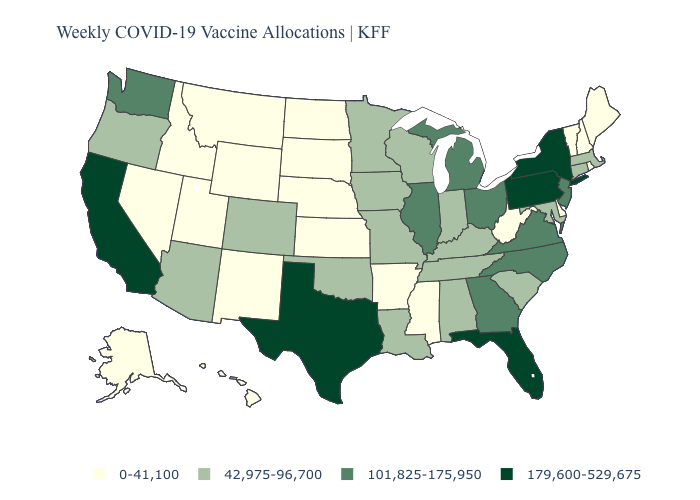Name the states that have a value in the range 179,600-529,675?
Concise answer only. California, Florida, New York, Pennsylvania, Texas. How many symbols are there in the legend?
Concise answer only. 4. What is the highest value in the MidWest ?
Short answer required. 101,825-175,950. Among the states that border Michigan , does Ohio have the highest value?
Give a very brief answer. Yes. What is the value of Kansas?
Be succinct. 0-41,100. What is the value of Texas?
Short answer required. 179,600-529,675. What is the lowest value in the USA?
Give a very brief answer. 0-41,100. What is the value of Virginia?
Answer briefly. 101,825-175,950. How many symbols are there in the legend?
Quick response, please. 4. What is the value of Indiana?
Answer briefly. 42,975-96,700. Name the states that have a value in the range 42,975-96,700?
Keep it brief. Alabama, Arizona, Colorado, Connecticut, Indiana, Iowa, Kentucky, Louisiana, Maryland, Massachusetts, Minnesota, Missouri, Oklahoma, Oregon, South Carolina, Tennessee, Wisconsin. What is the highest value in the Northeast ?
Answer briefly. 179,600-529,675. Name the states that have a value in the range 101,825-175,950?
Give a very brief answer. Georgia, Illinois, Michigan, New Jersey, North Carolina, Ohio, Virginia, Washington. How many symbols are there in the legend?
Concise answer only. 4. Which states hav the highest value in the Northeast?
Quick response, please. New York, Pennsylvania. 